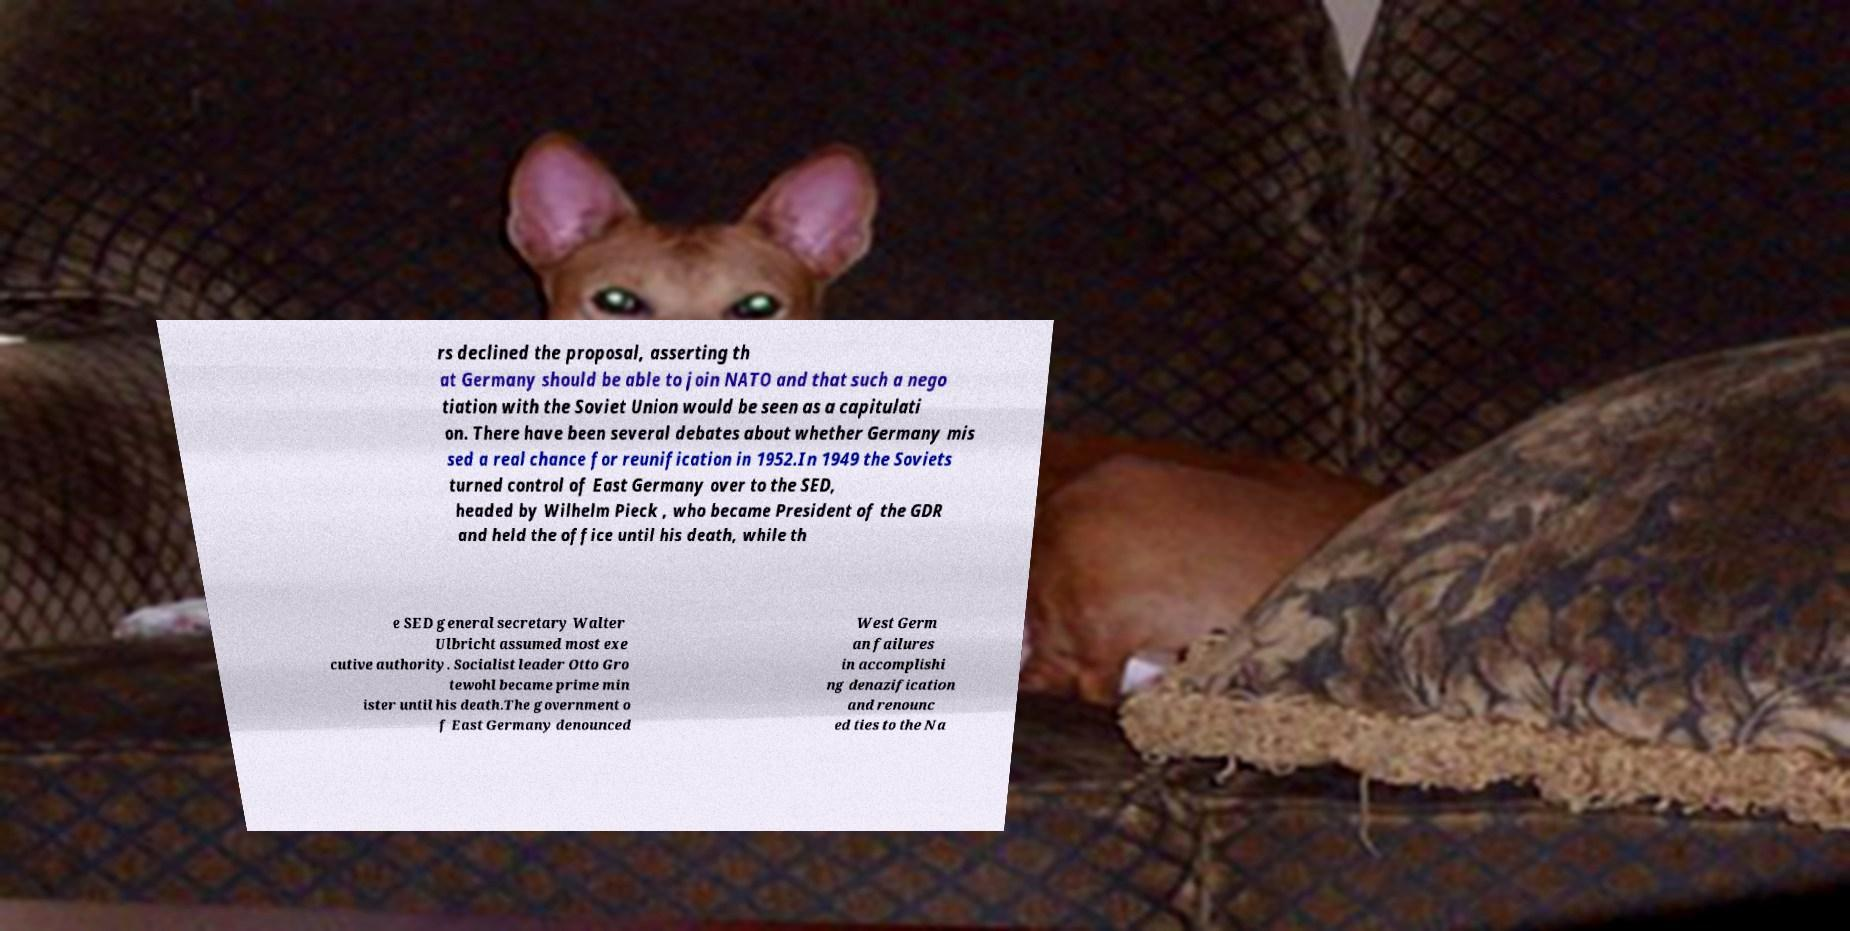Could you assist in decoding the text presented in this image and type it out clearly? rs declined the proposal, asserting th at Germany should be able to join NATO and that such a nego tiation with the Soviet Union would be seen as a capitulati on. There have been several debates about whether Germany mis sed a real chance for reunification in 1952.In 1949 the Soviets turned control of East Germany over to the SED, headed by Wilhelm Pieck , who became President of the GDR and held the office until his death, while th e SED general secretary Walter Ulbricht assumed most exe cutive authority. Socialist leader Otto Gro tewohl became prime min ister until his death.The government o f East Germany denounced West Germ an failures in accomplishi ng denazification and renounc ed ties to the Na 